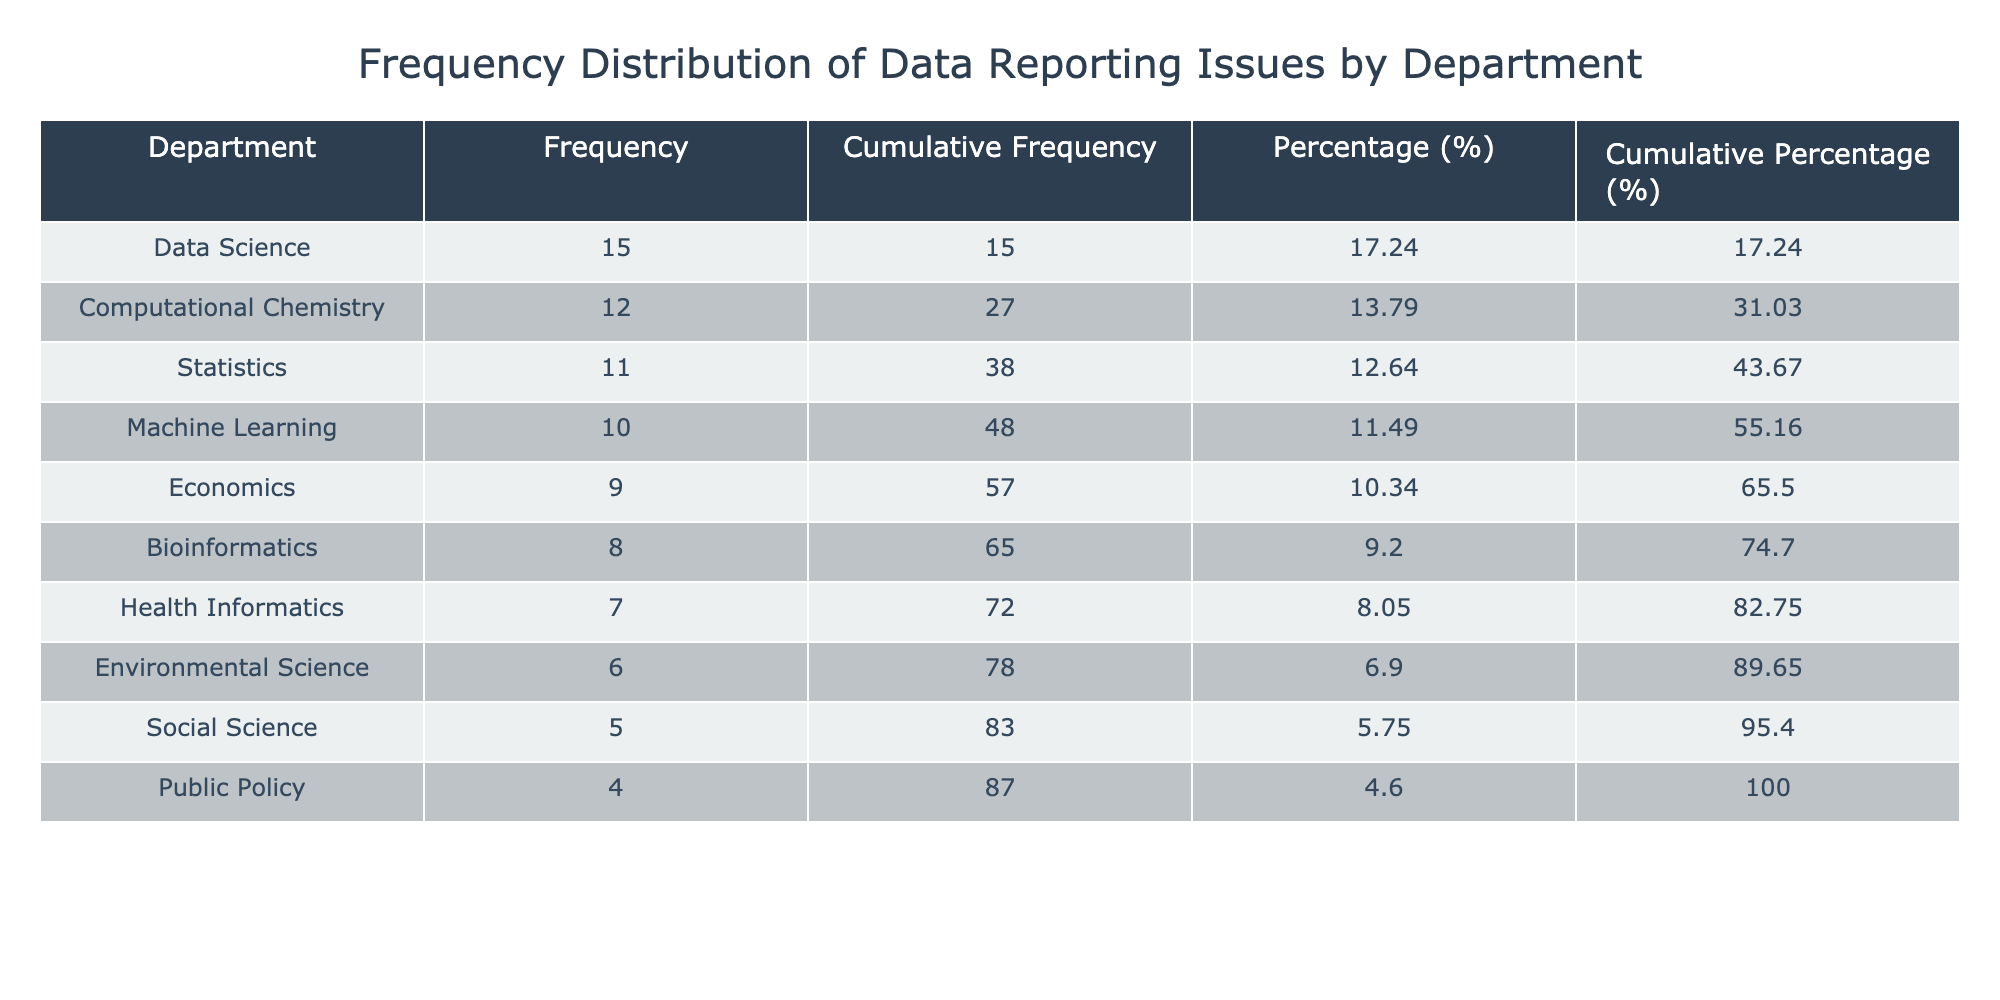What is the frequency of reporting issues in the Data Science department? The Data Science department has a reported frequency of 15 issues, which is directly available from the table.
Answer: 15 Which department has the lowest frequency of reporting issues? The Public Policy department has the lowest frequency of reporting issues at 4, as listed in the table.
Answer: Public Policy What is the cumulative frequency of reporting issues for the top two departments? To find this, we need to sum the frequencies of the top two departments: Data Science (15) and Computational Chemistry (12). Their cumulative frequency is 15 + 12 = 27.
Answer: 27 Is there a department that reported exactly 10 issues? Looking through the table, the Machine Learning department has reported exactly 10 issues.
Answer: Yes What is the total frequency of reporting issues across all departments? By summing the frequencies of all departments (15 + 8 + 12 + 5 + 9 + 6 + 11 + 7 + 10 + 4), we calculate the total to be 87.
Answer: 87 Which department has more reporting issues, Health Informatics or Environmental Science? Comparing the values from the table, Health Informatics reported 7 issues while Environmental Science reported 6. Thus, Health Informatics has more issues.
Answer: Health Informatics What percentage of the total reporting issues do the Statistics department's issues represent? The total frequency is 87, and the Statistics department reported 11 issues. To find the percentage, (11 / 87) * 100 = 12.64, so rounded it is 12.64%.
Answer: 12.64% What is the difference in frequencies between the department with the highest reports and the one with the lowest? The department with the highest frequency is Data Science (15) and the lowest is Public Policy (4). The difference is calculated as 15 - 4 = 11.
Answer: 11 Which two departments report fewer than 8 issues? From the table, the departments with fewer than 8 issues are Public Policy (4) and Social Science (5).
Answer: Public Policy and Social Science 